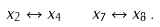<formula> <loc_0><loc_0><loc_500><loc_500>x _ { 2 } \leftrightarrow x _ { 4 } \quad x _ { 7 } \leftrightarrow x _ { 8 } \, .</formula> 